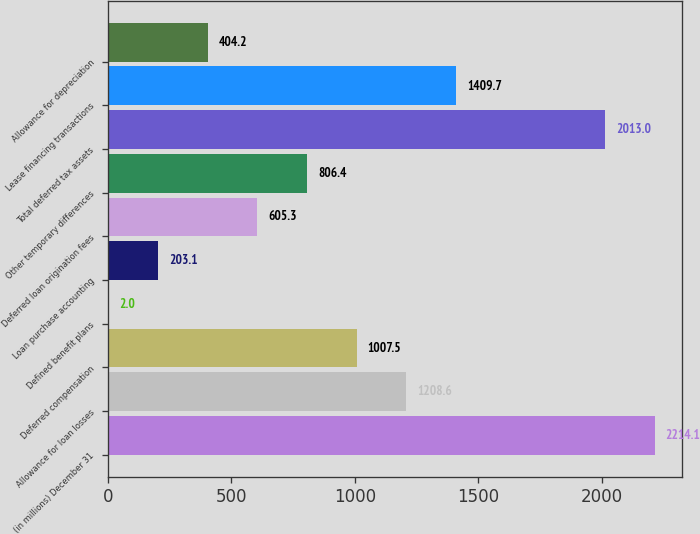Convert chart to OTSL. <chart><loc_0><loc_0><loc_500><loc_500><bar_chart><fcel>(in millions) December 31<fcel>Allowance for loan losses<fcel>Deferred compensation<fcel>Defined benefit plans<fcel>Loan purchase accounting<fcel>Deferred loan origination fees<fcel>Other temporary differences<fcel>Total deferred tax assets<fcel>Lease financing transactions<fcel>Allowance for depreciation<nl><fcel>2214.1<fcel>1208.6<fcel>1007.5<fcel>2<fcel>203.1<fcel>605.3<fcel>806.4<fcel>2013<fcel>1409.7<fcel>404.2<nl></chart> 